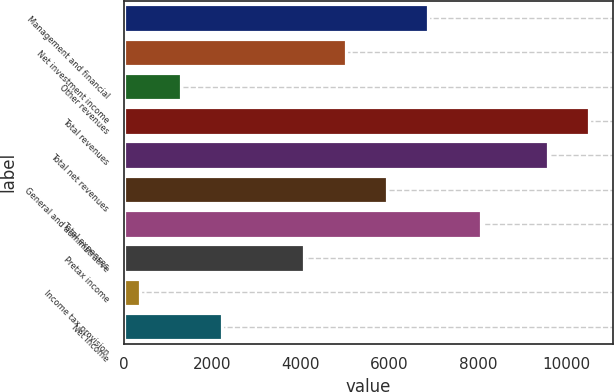Convert chart to OTSL. <chart><loc_0><loc_0><loc_500><loc_500><bar_chart><fcel>Management and financial<fcel>Net investment income<fcel>Other revenues<fcel>Total revenues<fcel>Total net revenues<fcel>General and administrative<fcel>Total expenses<fcel>Pretax income<fcel>Income tax provision<fcel>Net income<nl><fcel>6864<fcel>5006<fcel>1290<fcel>10510<fcel>9581<fcel>5935<fcel>8072<fcel>4077<fcel>361<fcel>2219<nl></chart> 